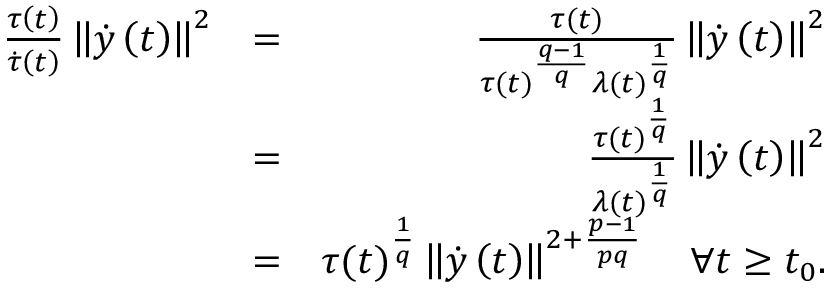Convert formula to latex. <formula><loc_0><loc_0><loc_500><loc_500>\begin{array} { r l r } { \frac { \tau \left ( t \right ) } { \dot { \tau } \left ( t \right ) } \left \| \dot { y } \left ( t \right ) \right \| ^ { 2 } } & { = } & { \frac { \tau ( t ) } { \tau ( t ) ^ { \frac { q - 1 } { q } } \lambda ( t ) ^ { \frac { 1 } { q } } } \left \| \dot { y } \left ( t \right ) \right \| ^ { 2 } } \\ & { = } & { \frac { \tau ( t ) ^ { \frac { 1 } { q } } } { \lambda ( t ) ^ { \frac { 1 } { q } } } \left \| \dot { y } \left ( t \right ) \right \| ^ { 2 } } \\ & { = } & { \tau ( t ) ^ { \frac { 1 } { q } } \left \| \dot { y } \left ( t \right ) \right \| ^ { 2 + \frac { p - 1 } { p q } } \quad \forall t \geq t _ { 0 } . } \end{array}</formula> 